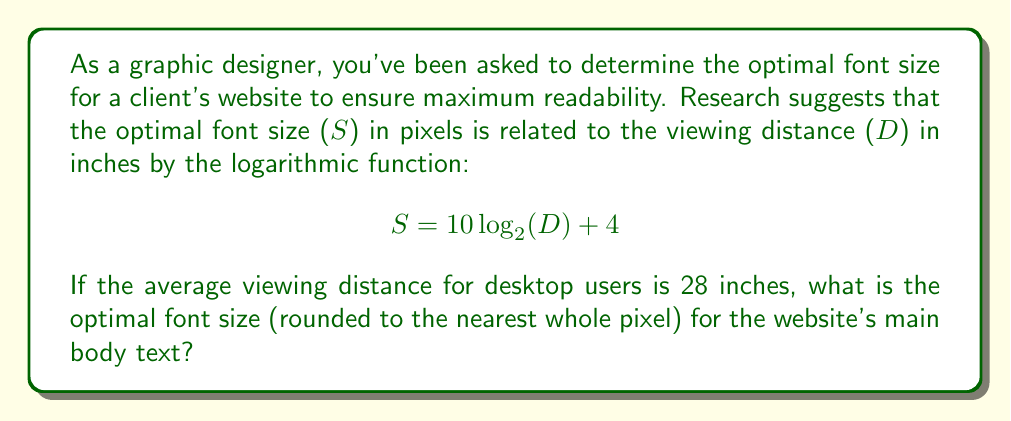Can you answer this question? To solve this problem, we'll follow these steps:

1. Identify the given information:
   - The formula: $S = 10 \log_{2}(D) + 4$
   - The viewing distance: $D = 28$ inches

2. Substitute the viewing distance into the formula:
   $$ S = 10 \log_{2}(28) + 4 $$

3. Calculate $\log_{2}(28)$:
   $2^4 = 16$ and $2^5 = 32$, so $28$ is between $2^4$ and $2^5$
   $\log_{2}(28) \approx 4.8074$

4. Multiply by 10 and add 4:
   $$ S = 10 \cdot 4.8074 + 4 $$
   $$ S = 48.074 + 4 = 52.074 $$

5. Round to the nearest whole pixel:
   $52.074$ rounds to $52$

Therefore, the optimal font size for the website's main body text is 52 pixels.
Answer: 52 pixels 